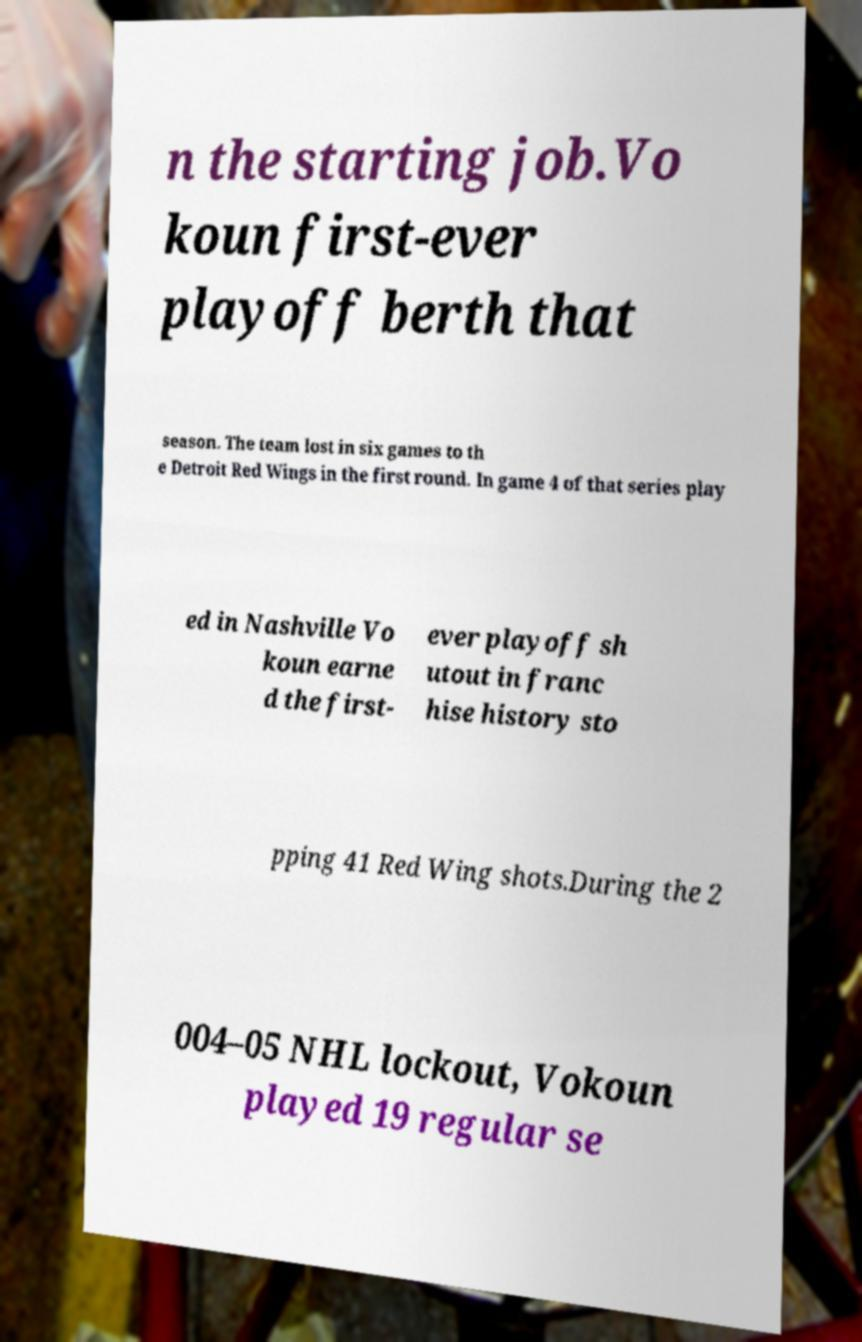I need the written content from this picture converted into text. Can you do that? n the starting job.Vo koun first-ever playoff berth that season. The team lost in six games to th e Detroit Red Wings in the first round. In game 4 of that series play ed in Nashville Vo koun earne d the first- ever playoff sh utout in franc hise history sto pping 41 Red Wing shots.During the 2 004–05 NHL lockout, Vokoun played 19 regular se 